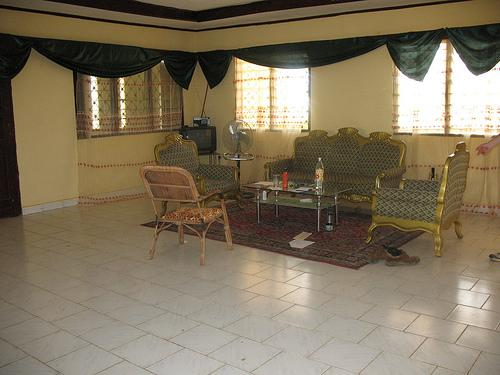Question: how many chairs are there?
Choices:
A. Two.
B. Three.
C. One.
D. Four.
Answer with the letter. Answer: B Question: what is in the corner?
Choices:
A. The tv.
B. The stereo.
C. The telephone.
D. The computer.
Answer with the letter. Answer: A Question: when was the photo taken?
Choices:
A. During the day.
B. Night.
C. Dawn.
D. Dusk.
Answer with the letter. Answer: A 